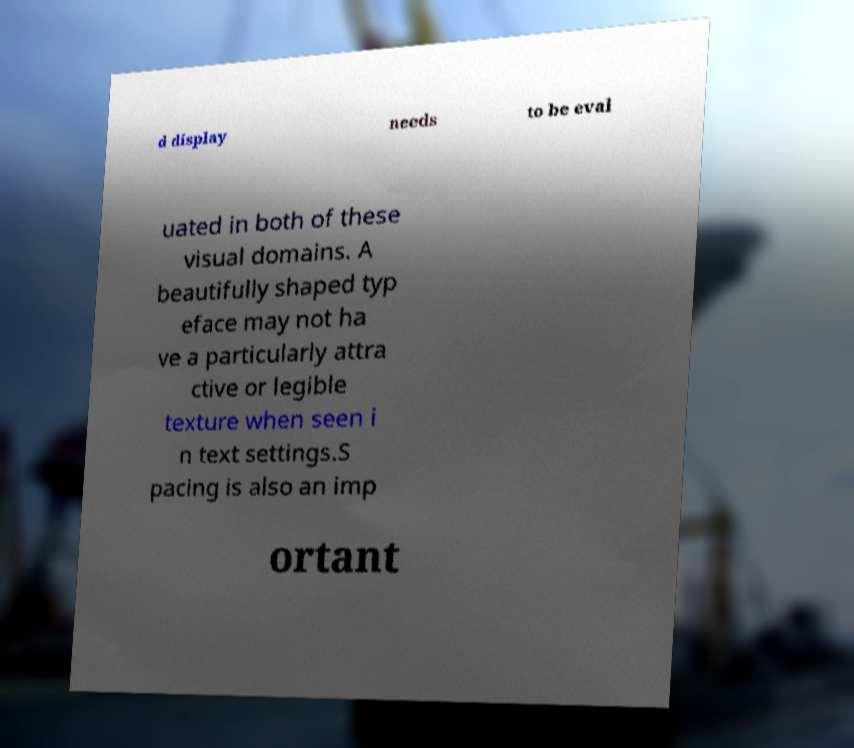There's text embedded in this image that I need extracted. Can you transcribe it verbatim? d display needs to be eval uated in both of these visual domains. A beautifully shaped typ eface may not ha ve a particularly attra ctive or legible texture when seen i n text settings.S pacing is also an imp ortant 